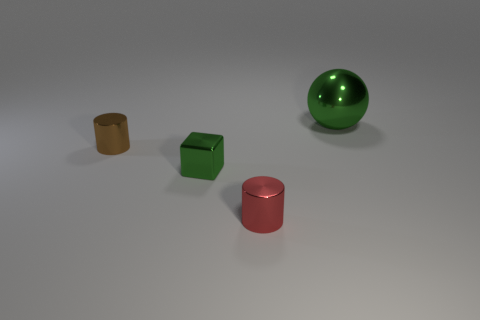Add 4 big blue metal balls. How many objects exist? 8 Subtract all spheres. How many objects are left? 3 Subtract all tiny cylinders. Subtract all cyan metal spheres. How many objects are left? 2 Add 3 tiny brown cylinders. How many tiny brown cylinders are left? 4 Add 1 brown rubber cylinders. How many brown rubber cylinders exist? 1 Subtract 0 red spheres. How many objects are left? 4 